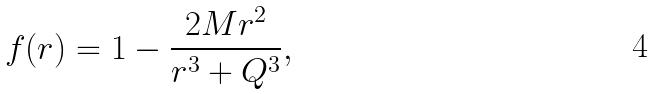Convert formula to latex. <formula><loc_0><loc_0><loc_500><loc_500>f ( r ) = 1 - \frac { 2 M r ^ { 2 } } { r ^ { 3 } + Q ^ { 3 } } ,</formula> 